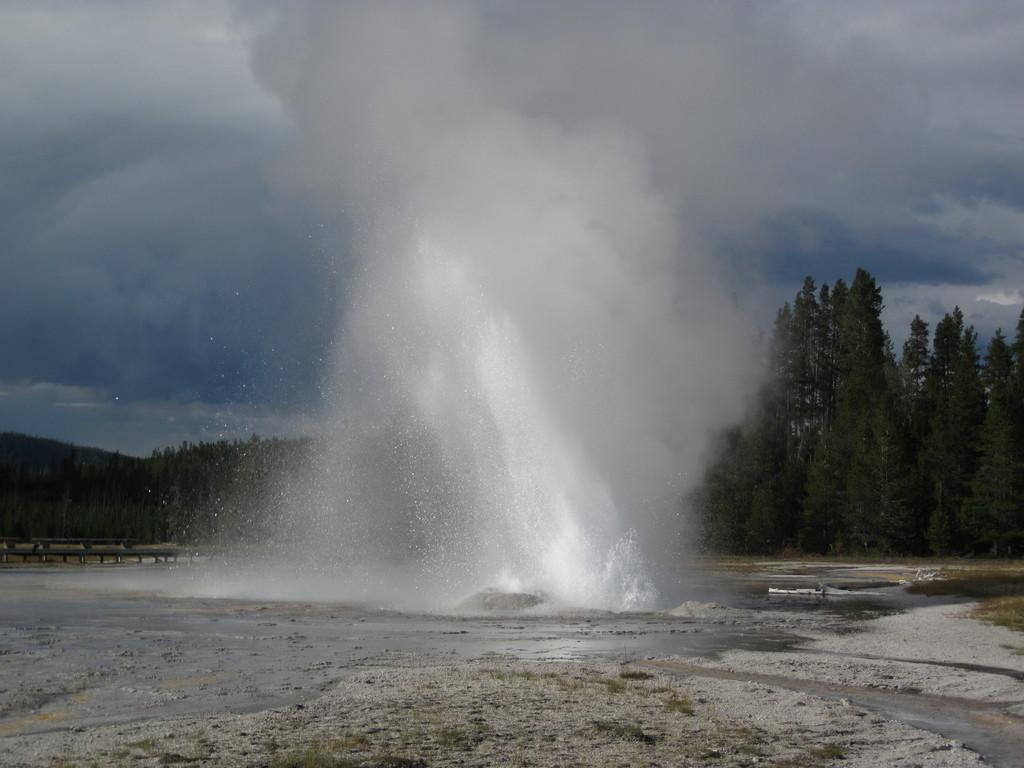What is in the foreground of the image? There is water in the foreground of the image. What can be seen in the background of the image? There are trees visible in the background of the image. What is visible at the top of the image? The sky is visible at the top of the image. What is the condition of the sky in the image? Clouds are present in the sky. What type of vegetation is present at the bottom of the image? Grass is present at the bottom of the image. What type of terrain is also present at the bottom of the image? Sand is present at the bottom of the image. What type of rice is being polished on the sidewalk in the image? There is no rice or sidewalk present in the image. What type of polish is being used on the rice on the sidewalk in the image? There is no rice or sidewalk present in the image, so no polish is being used. 